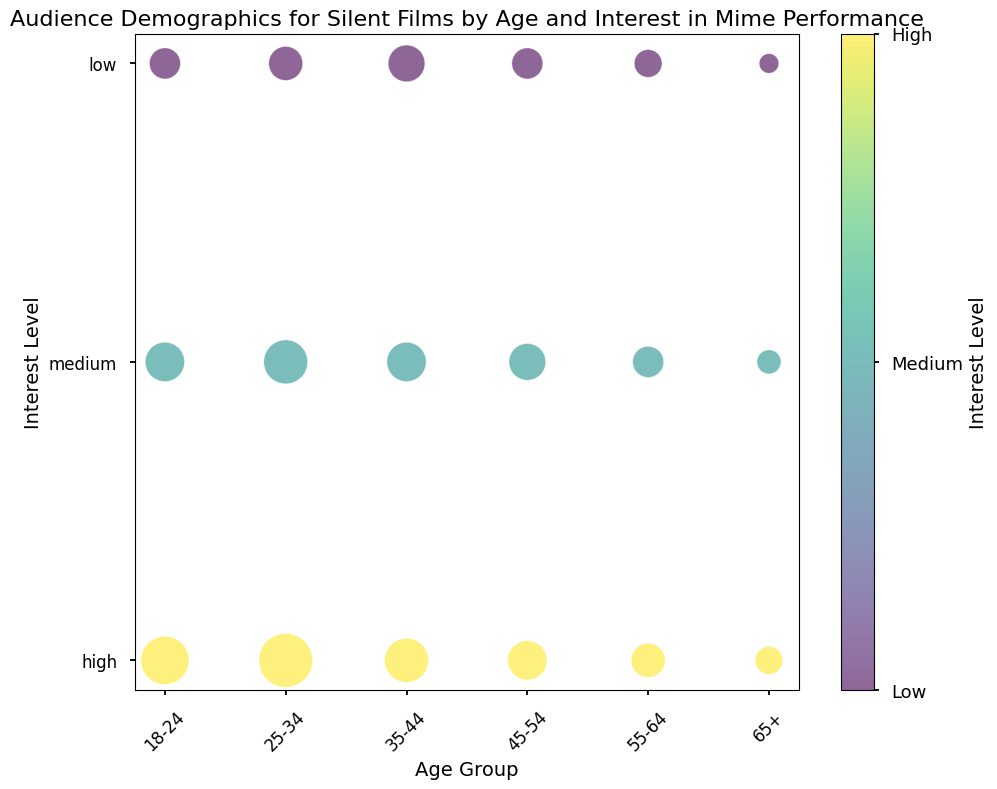What age group has the highest number of viewers with a high interest in mime performances? The bubble representing the age group 25-34 with high interest is the largest among the "high" interest level category. Therefore, this age group has the highest number of viewers with a high interest.
Answer: 25-34 Among the high interest level, which two age groups have the smallest and second smallest number of viewers? The bubble representing the age group 65+ is smallest, followed by the age group 55-64 among the "high" interest level category. These groups have the smallest and second smallest number of viewers, respectively.
Answer: 65+ and 55-64 Which interest level contains the most viewers in the age group 18-24? The largest bubble among the interest levels in the age group 18-24 corresponds to "high" interest.
Answer: High Compare the number of viewers with low interest in mime performance in the age group 25-34 and 65+. Which is larger and by how much? The bubble size for the low interest in age group 25-34 is larger than that of 65+. The difference in the number of viewers is 600 (25-34) - 200 (65+) = 400.
Answer: 25-34 by 400 How does the number of viewers with medium interest in mime performance in the age group 35-44 compare with those in the age group 45-54? The bubble size for medium interest in age group 35-44 and 45-54 appear almost equal in size, but the age group 35-44 has marginally more viewers, with both groups having bubbles in the middle range.
Answer: Slightly more in 35-44 Determine the total number of viewers with high interest in mime performance across all age groups. By summing all the viewers in each age group with high interest: 1200 (18-24) + 1500 (25-34) + 1000 (35-44) + 800 (45-54) + 600 (55-64) + 400 (65+), we get the total number. 1200 + 1500 + 1000 + 800 + 600 + 400 = 5500.
Answer: 5500 What is the average number of viewers with medium interest in mime performance in the age groups 18-24, 35-44, and 55-64? The number of viewers with medium interest in these age groups are 800 (18-24), 800 (35-44), and 500 (55-64). The total is 800 + 800 + 500 = 2100. Dividing this by 3 gives the average: 2100 / 3 = 700.
Answer: 700 Which age group has the least number of viewers with any interest level combined? Observing the bubble sizes, age group 65+ consistently has the smallest bubbles across all interest levels, indicating it has the least combined number of viewers.
Answer: 65+ 